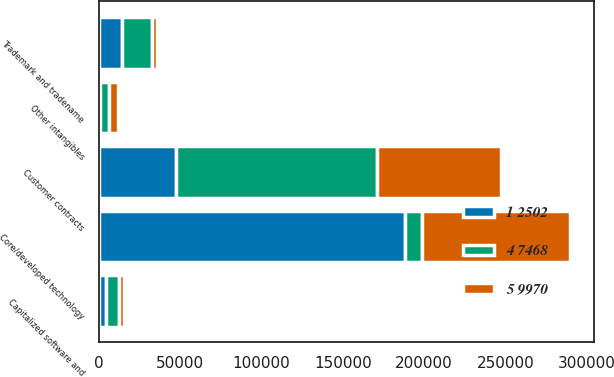<chart> <loc_0><loc_0><loc_500><loc_500><stacked_bar_chart><ecel><fcel>Core/developed technology<fcel>Customer contracts<fcel>Trademark and tradename<fcel>Other intangibles<fcel>Capitalized software and<nl><fcel>4 7468<fcel>11027.5<fcel>123540<fcel>18007<fcel>5993<fcel>7635<nl><fcel>1 2502<fcel>188023<fcel>47579<fcel>14420<fcel>397<fcel>4590<nl><fcel>5 9970<fcel>91087<fcel>75961<fcel>3587<fcel>5596<fcel>3045<nl></chart> 